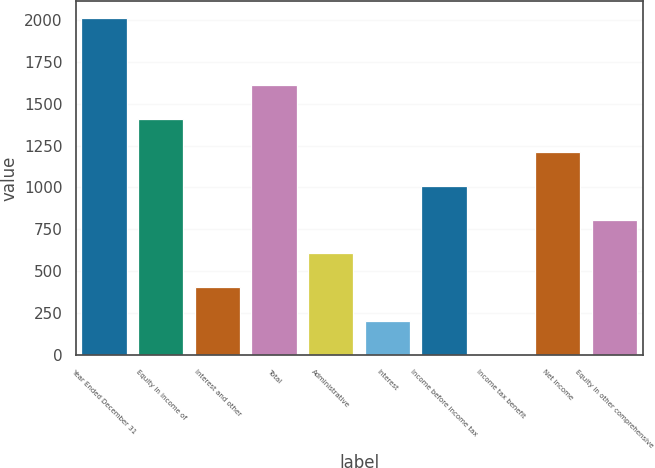Convert chart. <chart><loc_0><loc_0><loc_500><loc_500><bar_chart><fcel>Year Ended December 31<fcel>Equity in income of<fcel>Interest and other<fcel>Total<fcel>Administrative<fcel>Interest<fcel>Income before income tax<fcel>Income tax benefit<fcel>Net income<fcel>Equity in other comprehensive<nl><fcel>2012<fcel>1409.9<fcel>406.4<fcel>1610.6<fcel>607.1<fcel>205.7<fcel>1008.5<fcel>5<fcel>1209.2<fcel>807.8<nl></chart> 